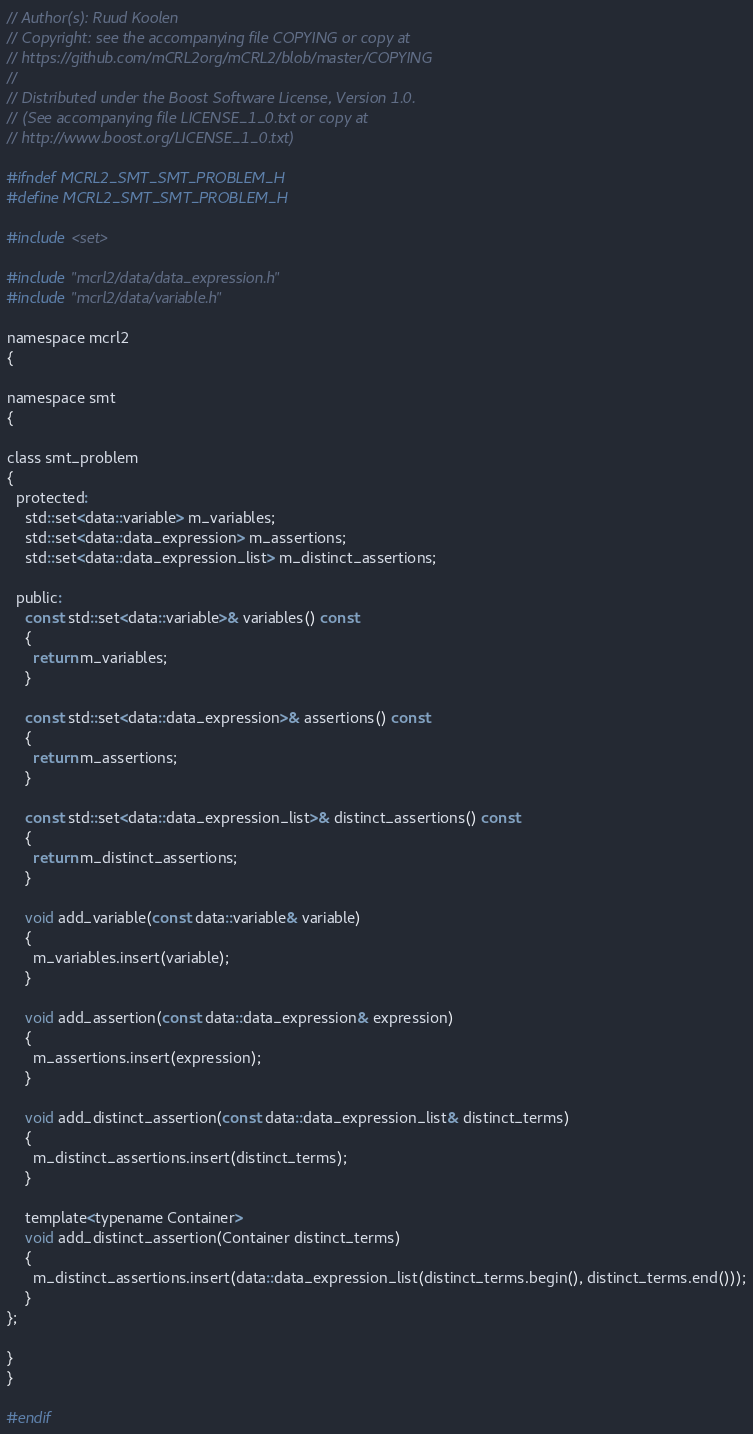<code> <loc_0><loc_0><loc_500><loc_500><_C_>// Author(s): Ruud Koolen
// Copyright: see the accompanying file COPYING or copy at
// https://github.com/mCRL2org/mCRL2/blob/master/COPYING
//
// Distributed under the Boost Software License, Version 1.0.
// (See accompanying file LICENSE_1_0.txt or copy at
// http://www.boost.org/LICENSE_1_0.txt)

#ifndef MCRL2_SMT_SMT_PROBLEM_H
#define MCRL2_SMT_SMT_PROBLEM_H

#include <set>

#include "mcrl2/data/data_expression.h"
#include "mcrl2/data/variable.h"

namespace mcrl2
{

namespace smt
{

class smt_problem
{
  protected:
    std::set<data::variable> m_variables;
    std::set<data::data_expression> m_assertions;
    std::set<data::data_expression_list> m_distinct_assertions;

  public:
    const std::set<data::variable>& variables() const
    {
      return m_variables;
    }

    const std::set<data::data_expression>& assertions() const
    {
      return m_assertions;
    }

    const std::set<data::data_expression_list>& distinct_assertions() const
    {
      return m_distinct_assertions;
    }

    void add_variable(const data::variable& variable)
    {
      m_variables.insert(variable);
    }

    void add_assertion(const data::data_expression& expression)
    {
      m_assertions.insert(expression);
    }

    void add_distinct_assertion(const data::data_expression_list& distinct_terms)
    {
      m_distinct_assertions.insert(distinct_terms);
    }

    template<typename Container>
    void add_distinct_assertion(Container distinct_terms)
    {
      m_distinct_assertions.insert(data::data_expression_list(distinct_terms.begin(), distinct_terms.end()));
    }
};

}
}

#endif
</code> 